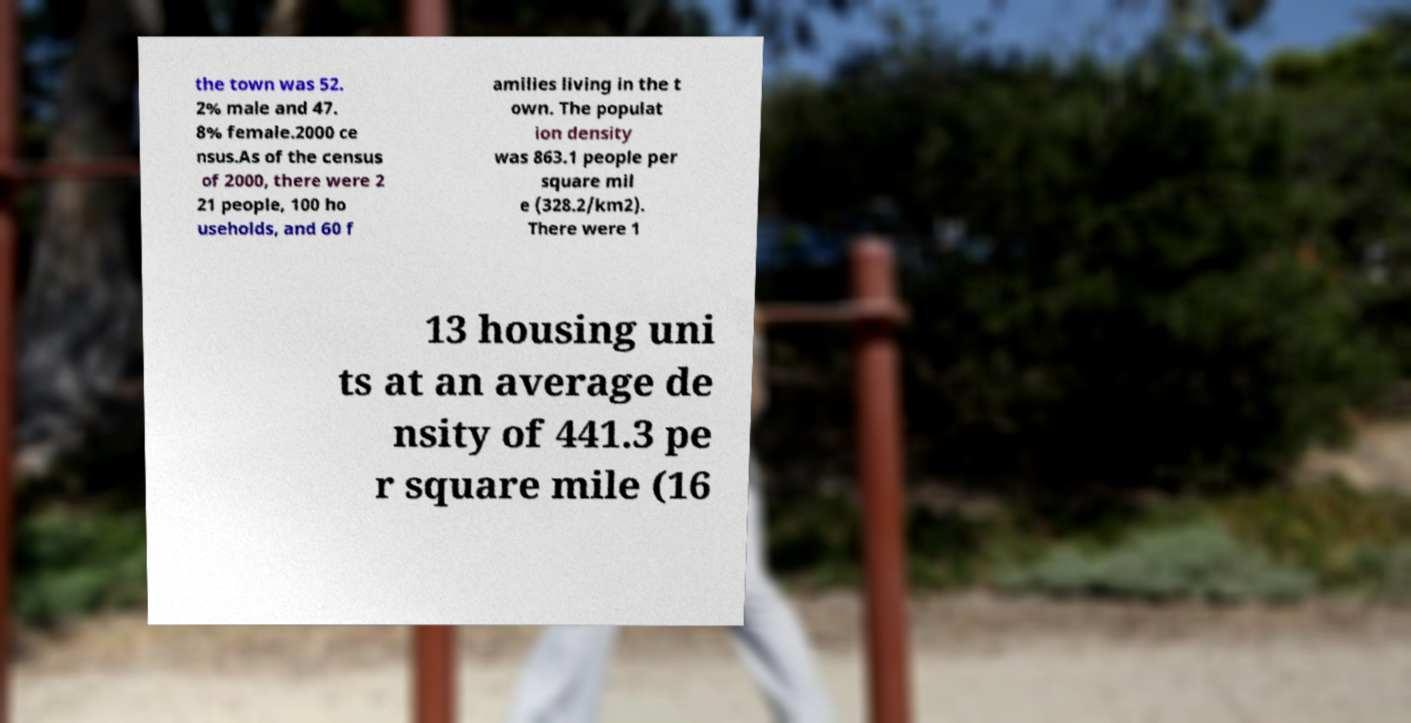Could you extract and type out the text from this image? the town was 52. 2% male and 47. 8% female.2000 ce nsus.As of the census of 2000, there were 2 21 people, 100 ho useholds, and 60 f amilies living in the t own. The populat ion density was 863.1 people per square mil e (328.2/km2). There were 1 13 housing uni ts at an average de nsity of 441.3 pe r square mile (16 